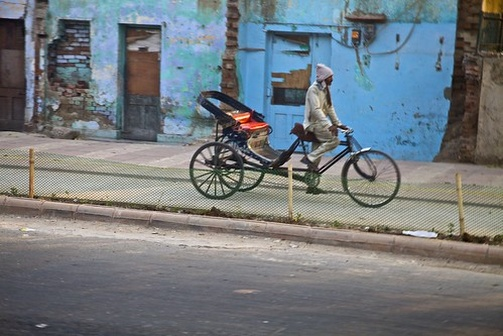Describe the scene and discuss what it suggests about the local community. The image depicts a man riding a red tricycle along a street, which hints at a community that values both practicality and tradition. The man is taking safety precautions by wearing a helmet, which shows awareness and responsibility. The background consists of an old blue building with a green fence and discarded items on the sidewalk, suggesting that this area may not receive regular maintenance, reflecting economic challenges or community neglect. Nonetheless, the presence of such activity indicates that the area continues to be an active part of daily life. 